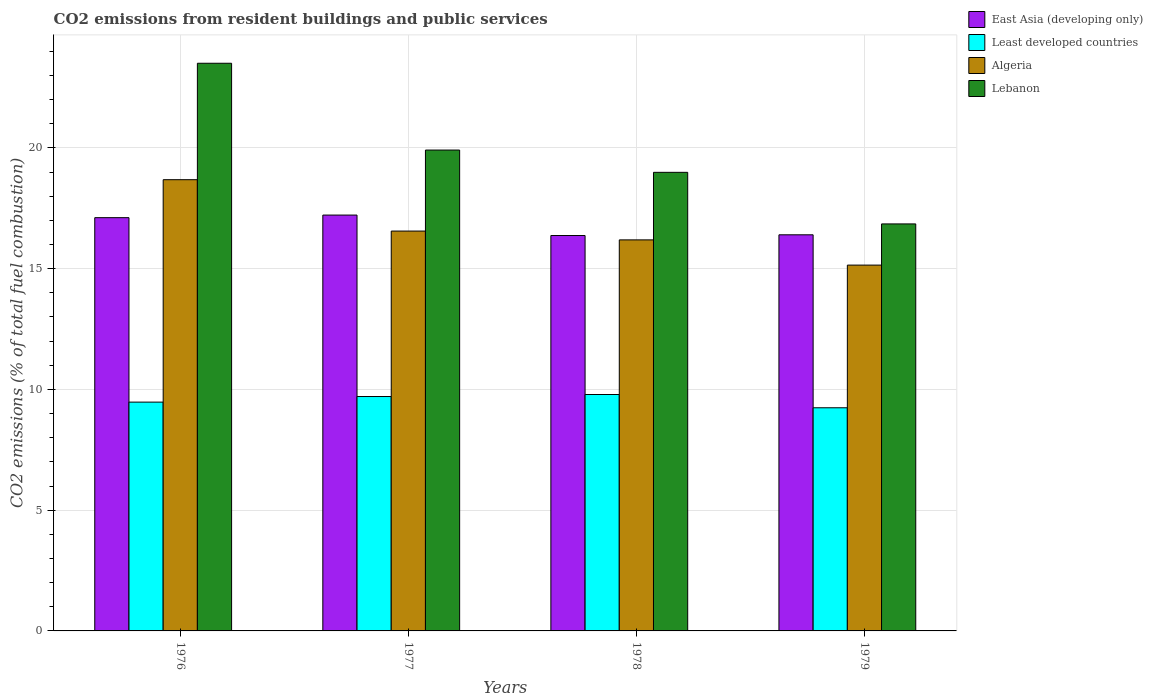How many different coloured bars are there?
Provide a short and direct response. 4. How many groups of bars are there?
Your answer should be very brief. 4. Are the number of bars on each tick of the X-axis equal?
Your response must be concise. Yes. How many bars are there on the 3rd tick from the left?
Offer a very short reply. 4. In how many cases, is the number of bars for a given year not equal to the number of legend labels?
Make the answer very short. 0. What is the total CO2 emitted in Least developed countries in 1979?
Offer a very short reply. 9.24. Across all years, what is the maximum total CO2 emitted in East Asia (developing only)?
Provide a short and direct response. 17.22. Across all years, what is the minimum total CO2 emitted in Lebanon?
Your response must be concise. 16.85. In which year was the total CO2 emitted in Lebanon maximum?
Ensure brevity in your answer.  1976. In which year was the total CO2 emitted in East Asia (developing only) minimum?
Offer a terse response. 1978. What is the total total CO2 emitted in Algeria in the graph?
Your response must be concise. 66.58. What is the difference between the total CO2 emitted in Lebanon in 1978 and that in 1979?
Your response must be concise. 2.14. What is the difference between the total CO2 emitted in Lebanon in 1977 and the total CO2 emitted in East Asia (developing only) in 1976?
Give a very brief answer. 2.8. What is the average total CO2 emitted in East Asia (developing only) per year?
Give a very brief answer. 16.78. In the year 1978, what is the difference between the total CO2 emitted in Least developed countries and total CO2 emitted in Lebanon?
Ensure brevity in your answer.  -9.2. In how many years, is the total CO2 emitted in East Asia (developing only) greater than 8?
Keep it short and to the point. 4. What is the ratio of the total CO2 emitted in Least developed countries in 1976 to that in 1979?
Your answer should be compact. 1.03. Is the difference between the total CO2 emitted in Least developed countries in 1976 and 1978 greater than the difference between the total CO2 emitted in Lebanon in 1976 and 1978?
Offer a very short reply. No. What is the difference between the highest and the second highest total CO2 emitted in Lebanon?
Ensure brevity in your answer.  3.59. What is the difference between the highest and the lowest total CO2 emitted in Lebanon?
Your answer should be very brief. 6.65. In how many years, is the total CO2 emitted in East Asia (developing only) greater than the average total CO2 emitted in East Asia (developing only) taken over all years?
Offer a terse response. 2. What does the 4th bar from the left in 1978 represents?
Give a very brief answer. Lebanon. What does the 1st bar from the right in 1979 represents?
Provide a succinct answer. Lebanon. Is it the case that in every year, the sum of the total CO2 emitted in Lebanon and total CO2 emitted in East Asia (developing only) is greater than the total CO2 emitted in Least developed countries?
Make the answer very short. Yes. How many years are there in the graph?
Make the answer very short. 4. What is the difference between two consecutive major ticks on the Y-axis?
Ensure brevity in your answer.  5. Does the graph contain any zero values?
Your response must be concise. No. How are the legend labels stacked?
Provide a short and direct response. Vertical. What is the title of the graph?
Your answer should be very brief. CO2 emissions from resident buildings and public services. What is the label or title of the Y-axis?
Provide a short and direct response. CO2 emissions (% of total fuel combustion). What is the CO2 emissions (% of total fuel combustion) in East Asia (developing only) in 1976?
Offer a very short reply. 17.11. What is the CO2 emissions (% of total fuel combustion) in Least developed countries in 1976?
Ensure brevity in your answer.  9.47. What is the CO2 emissions (% of total fuel combustion) of Algeria in 1976?
Ensure brevity in your answer.  18.69. What is the CO2 emissions (% of total fuel combustion) in Lebanon in 1976?
Your answer should be very brief. 23.51. What is the CO2 emissions (% of total fuel combustion) in East Asia (developing only) in 1977?
Your answer should be very brief. 17.22. What is the CO2 emissions (% of total fuel combustion) in Least developed countries in 1977?
Ensure brevity in your answer.  9.71. What is the CO2 emissions (% of total fuel combustion) of Algeria in 1977?
Give a very brief answer. 16.56. What is the CO2 emissions (% of total fuel combustion) of Lebanon in 1977?
Keep it short and to the point. 19.91. What is the CO2 emissions (% of total fuel combustion) in East Asia (developing only) in 1978?
Provide a short and direct response. 16.37. What is the CO2 emissions (% of total fuel combustion) of Least developed countries in 1978?
Keep it short and to the point. 9.79. What is the CO2 emissions (% of total fuel combustion) in Algeria in 1978?
Your answer should be compact. 16.19. What is the CO2 emissions (% of total fuel combustion) in Lebanon in 1978?
Give a very brief answer. 18.99. What is the CO2 emissions (% of total fuel combustion) in East Asia (developing only) in 1979?
Your answer should be compact. 16.4. What is the CO2 emissions (% of total fuel combustion) in Least developed countries in 1979?
Keep it short and to the point. 9.24. What is the CO2 emissions (% of total fuel combustion) of Algeria in 1979?
Make the answer very short. 15.15. What is the CO2 emissions (% of total fuel combustion) of Lebanon in 1979?
Your answer should be very brief. 16.85. Across all years, what is the maximum CO2 emissions (% of total fuel combustion) in East Asia (developing only)?
Ensure brevity in your answer.  17.22. Across all years, what is the maximum CO2 emissions (% of total fuel combustion) of Least developed countries?
Your answer should be very brief. 9.79. Across all years, what is the maximum CO2 emissions (% of total fuel combustion) of Algeria?
Offer a terse response. 18.69. Across all years, what is the maximum CO2 emissions (% of total fuel combustion) in Lebanon?
Offer a very short reply. 23.51. Across all years, what is the minimum CO2 emissions (% of total fuel combustion) in East Asia (developing only)?
Make the answer very short. 16.37. Across all years, what is the minimum CO2 emissions (% of total fuel combustion) of Least developed countries?
Your response must be concise. 9.24. Across all years, what is the minimum CO2 emissions (% of total fuel combustion) of Algeria?
Your answer should be compact. 15.15. Across all years, what is the minimum CO2 emissions (% of total fuel combustion) in Lebanon?
Give a very brief answer. 16.85. What is the total CO2 emissions (% of total fuel combustion) of East Asia (developing only) in the graph?
Your answer should be very brief. 67.11. What is the total CO2 emissions (% of total fuel combustion) in Least developed countries in the graph?
Make the answer very short. 38.21. What is the total CO2 emissions (% of total fuel combustion) of Algeria in the graph?
Your answer should be very brief. 66.58. What is the total CO2 emissions (% of total fuel combustion) in Lebanon in the graph?
Make the answer very short. 79.26. What is the difference between the CO2 emissions (% of total fuel combustion) of East Asia (developing only) in 1976 and that in 1977?
Your response must be concise. -0.11. What is the difference between the CO2 emissions (% of total fuel combustion) of Least developed countries in 1976 and that in 1977?
Your answer should be compact. -0.23. What is the difference between the CO2 emissions (% of total fuel combustion) of Algeria in 1976 and that in 1977?
Provide a short and direct response. 2.13. What is the difference between the CO2 emissions (% of total fuel combustion) of Lebanon in 1976 and that in 1977?
Your answer should be compact. 3.59. What is the difference between the CO2 emissions (% of total fuel combustion) of East Asia (developing only) in 1976 and that in 1978?
Keep it short and to the point. 0.74. What is the difference between the CO2 emissions (% of total fuel combustion) in Least developed countries in 1976 and that in 1978?
Offer a terse response. -0.32. What is the difference between the CO2 emissions (% of total fuel combustion) of Algeria in 1976 and that in 1978?
Provide a short and direct response. 2.49. What is the difference between the CO2 emissions (% of total fuel combustion) of Lebanon in 1976 and that in 1978?
Give a very brief answer. 4.52. What is the difference between the CO2 emissions (% of total fuel combustion) in East Asia (developing only) in 1976 and that in 1979?
Your answer should be very brief. 0.71. What is the difference between the CO2 emissions (% of total fuel combustion) of Least developed countries in 1976 and that in 1979?
Your response must be concise. 0.23. What is the difference between the CO2 emissions (% of total fuel combustion) in Algeria in 1976 and that in 1979?
Offer a terse response. 3.54. What is the difference between the CO2 emissions (% of total fuel combustion) of Lebanon in 1976 and that in 1979?
Your response must be concise. 6.65. What is the difference between the CO2 emissions (% of total fuel combustion) in East Asia (developing only) in 1977 and that in 1978?
Your answer should be very brief. 0.85. What is the difference between the CO2 emissions (% of total fuel combustion) of Least developed countries in 1977 and that in 1978?
Your answer should be very brief. -0.08. What is the difference between the CO2 emissions (% of total fuel combustion) in Algeria in 1977 and that in 1978?
Your response must be concise. 0.36. What is the difference between the CO2 emissions (% of total fuel combustion) in Lebanon in 1977 and that in 1978?
Offer a very short reply. 0.92. What is the difference between the CO2 emissions (% of total fuel combustion) of East Asia (developing only) in 1977 and that in 1979?
Provide a succinct answer. 0.82. What is the difference between the CO2 emissions (% of total fuel combustion) of Least developed countries in 1977 and that in 1979?
Provide a succinct answer. 0.47. What is the difference between the CO2 emissions (% of total fuel combustion) of Algeria in 1977 and that in 1979?
Offer a terse response. 1.41. What is the difference between the CO2 emissions (% of total fuel combustion) of Lebanon in 1977 and that in 1979?
Make the answer very short. 3.06. What is the difference between the CO2 emissions (% of total fuel combustion) of East Asia (developing only) in 1978 and that in 1979?
Keep it short and to the point. -0.03. What is the difference between the CO2 emissions (% of total fuel combustion) in Least developed countries in 1978 and that in 1979?
Provide a succinct answer. 0.55. What is the difference between the CO2 emissions (% of total fuel combustion) in Algeria in 1978 and that in 1979?
Keep it short and to the point. 1.04. What is the difference between the CO2 emissions (% of total fuel combustion) of Lebanon in 1978 and that in 1979?
Your answer should be very brief. 2.14. What is the difference between the CO2 emissions (% of total fuel combustion) in East Asia (developing only) in 1976 and the CO2 emissions (% of total fuel combustion) in Least developed countries in 1977?
Offer a very short reply. 7.41. What is the difference between the CO2 emissions (% of total fuel combustion) of East Asia (developing only) in 1976 and the CO2 emissions (% of total fuel combustion) of Algeria in 1977?
Offer a terse response. 0.56. What is the difference between the CO2 emissions (% of total fuel combustion) in East Asia (developing only) in 1976 and the CO2 emissions (% of total fuel combustion) in Lebanon in 1977?
Keep it short and to the point. -2.8. What is the difference between the CO2 emissions (% of total fuel combustion) in Least developed countries in 1976 and the CO2 emissions (% of total fuel combustion) in Algeria in 1977?
Your answer should be compact. -7.08. What is the difference between the CO2 emissions (% of total fuel combustion) of Least developed countries in 1976 and the CO2 emissions (% of total fuel combustion) of Lebanon in 1977?
Keep it short and to the point. -10.44. What is the difference between the CO2 emissions (% of total fuel combustion) in Algeria in 1976 and the CO2 emissions (% of total fuel combustion) in Lebanon in 1977?
Give a very brief answer. -1.23. What is the difference between the CO2 emissions (% of total fuel combustion) of East Asia (developing only) in 1976 and the CO2 emissions (% of total fuel combustion) of Least developed countries in 1978?
Your answer should be very brief. 7.32. What is the difference between the CO2 emissions (% of total fuel combustion) of East Asia (developing only) in 1976 and the CO2 emissions (% of total fuel combustion) of Algeria in 1978?
Your response must be concise. 0.92. What is the difference between the CO2 emissions (% of total fuel combustion) of East Asia (developing only) in 1976 and the CO2 emissions (% of total fuel combustion) of Lebanon in 1978?
Your answer should be very brief. -1.88. What is the difference between the CO2 emissions (% of total fuel combustion) of Least developed countries in 1976 and the CO2 emissions (% of total fuel combustion) of Algeria in 1978?
Your answer should be very brief. -6.72. What is the difference between the CO2 emissions (% of total fuel combustion) of Least developed countries in 1976 and the CO2 emissions (% of total fuel combustion) of Lebanon in 1978?
Your answer should be very brief. -9.51. What is the difference between the CO2 emissions (% of total fuel combustion) of Algeria in 1976 and the CO2 emissions (% of total fuel combustion) of Lebanon in 1978?
Make the answer very short. -0.3. What is the difference between the CO2 emissions (% of total fuel combustion) of East Asia (developing only) in 1976 and the CO2 emissions (% of total fuel combustion) of Least developed countries in 1979?
Make the answer very short. 7.87. What is the difference between the CO2 emissions (% of total fuel combustion) of East Asia (developing only) in 1976 and the CO2 emissions (% of total fuel combustion) of Algeria in 1979?
Your answer should be very brief. 1.96. What is the difference between the CO2 emissions (% of total fuel combustion) in East Asia (developing only) in 1976 and the CO2 emissions (% of total fuel combustion) in Lebanon in 1979?
Your answer should be very brief. 0.26. What is the difference between the CO2 emissions (% of total fuel combustion) of Least developed countries in 1976 and the CO2 emissions (% of total fuel combustion) of Algeria in 1979?
Your answer should be very brief. -5.67. What is the difference between the CO2 emissions (% of total fuel combustion) of Least developed countries in 1976 and the CO2 emissions (% of total fuel combustion) of Lebanon in 1979?
Ensure brevity in your answer.  -7.38. What is the difference between the CO2 emissions (% of total fuel combustion) of Algeria in 1976 and the CO2 emissions (% of total fuel combustion) of Lebanon in 1979?
Give a very brief answer. 1.83. What is the difference between the CO2 emissions (% of total fuel combustion) in East Asia (developing only) in 1977 and the CO2 emissions (% of total fuel combustion) in Least developed countries in 1978?
Offer a very short reply. 7.43. What is the difference between the CO2 emissions (% of total fuel combustion) in East Asia (developing only) in 1977 and the CO2 emissions (% of total fuel combustion) in Algeria in 1978?
Provide a short and direct response. 1.03. What is the difference between the CO2 emissions (% of total fuel combustion) of East Asia (developing only) in 1977 and the CO2 emissions (% of total fuel combustion) of Lebanon in 1978?
Offer a terse response. -1.77. What is the difference between the CO2 emissions (% of total fuel combustion) in Least developed countries in 1977 and the CO2 emissions (% of total fuel combustion) in Algeria in 1978?
Make the answer very short. -6.49. What is the difference between the CO2 emissions (% of total fuel combustion) of Least developed countries in 1977 and the CO2 emissions (% of total fuel combustion) of Lebanon in 1978?
Offer a terse response. -9.28. What is the difference between the CO2 emissions (% of total fuel combustion) in Algeria in 1977 and the CO2 emissions (% of total fuel combustion) in Lebanon in 1978?
Keep it short and to the point. -2.43. What is the difference between the CO2 emissions (% of total fuel combustion) of East Asia (developing only) in 1977 and the CO2 emissions (% of total fuel combustion) of Least developed countries in 1979?
Your answer should be compact. 7.98. What is the difference between the CO2 emissions (% of total fuel combustion) in East Asia (developing only) in 1977 and the CO2 emissions (% of total fuel combustion) in Algeria in 1979?
Your response must be concise. 2.07. What is the difference between the CO2 emissions (% of total fuel combustion) of East Asia (developing only) in 1977 and the CO2 emissions (% of total fuel combustion) of Lebanon in 1979?
Make the answer very short. 0.37. What is the difference between the CO2 emissions (% of total fuel combustion) in Least developed countries in 1977 and the CO2 emissions (% of total fuel combustion) in Algeria in 1979?
Make the answer very short. -5.44. What is the difference between the CO2 emissions (% of total fuel combustion) of Least developed countries in 1977 and the CO2 emissions (% of total fuel combustion) of Lebanon in 1979?
Offer a very short reply. -7.15. What is the difference between the CO2 emissions (% of total fuel combustion) of Algeria in 1977 and the CO2 emissions (% of total fuel combustion) of Lebanon in 1979?
Your answer should be compact. -0.3. What is the difference between the CO2 emissions (% of total fuel combustion) in East Asia (developing only) in 1978 and the CO2 emissions (% of total fuel combustion) in Least developed countries in 1979?
Your answer should be very brief. 7.13. What is the difference between the CO2 emissions (% of total fuel combustion) of East Asia (developing only) in 1978 and the CO2 emissions (% of total fuel combustion) of Algeria in 1979?
Your answer should be very brief. 1.23. What is the difference between the CO2 emissions (% of total fuel combustion) of East Asia (developing only) in 1978 and the CO2 emissions (% of total fuel combustion) of Lebanon in 1979?
Make the answer very short. -0.48. What is the difference between the CO2 emissions (% of total fuel combustion) in Least developed countries in 1978 and the CO2 emissions (% of total fuel combustion) in Algeria in 1979?
Provide a short and direct response. -5.36. What is the difference between the CO2 emissions (% of total fuel combustion) in Least developed countries in 1978 and the CO2 emissions (% of total fuel combustion) in Lebanon in 1979?
Your answer should be compact. -7.06. What is the difference between the CO2 emissions (% of total fuel combustion) in Algeria in 1978 and the CO2 emissions (% of total fuel combustion) in Lebanon in 1979?
Your answer should be compact. -0.66. What is the average CO2 emissions (% of total fuel combustion) in East Asia (developing only) per year?
Ensure brevity in your answer.  16.78. What is the average CO2 emissions (% of total fuel combustion) of Least developed countries per year?
Your answer should be very brief. 9.55. What is the average CO2 emissions (% of total fuel combustion) in Algeria per year?
Offer a very short reply. 16.65. What is the average CO2 emissions (% of total fuel combustion) of Lebanon per year?
Make the answer very short. 19.82. In the year 1976, what is the difference between the CO2 emissions (% of total fuel combustion) in East Asia (developing only) and CO2 emissions (% of total fuel combustion) in Least developed countries?
Offer a very short reply. 7.64. In the year 1976, what is the difference between the CO2 emissions (% of total fuel combustion) of East Asia (developing only) and CO2 emissions (% of total fuel combustion) of Algeria?
Keep it short and to the point. -1.57. In the year 1976, what is the difference between the CO2 emissions (% of total fuel combustion) in East Asia (developing only) and CO2 emissions (% of total fuel combustion) in Lebanon?
Your answer should be compact. -6.39. In the year 1976, what is the difference between the CO2 emissions (% of total fuel combustion) of Least developed countries and CO2 emissions (% of total fuel combustion) of Algeria?
Provide a succinct answer. -9.21. In the year 1976, what is the difference between the CO2 emissions (% of total fuel combustion) of Least developed countries and CO2 emissions (% of total fuel combustion) of Lebanon?
Your answer should be very brief. -14.03. In the year 1976, what is the difference between the CO2 emissions (% of total fuel combustion) in Algeria and CO2 emissions (% of total fuel combustion) in Lebanon?
Your answer should be compact. -4.82. In the year 1977, what is the difference between the CO2 emissions (% of total fuel combustion) in East Asia (developing only) and CO2 emissions (% of total fuel combustion) in Least developed countries?
Your answer should be compact. 7.51. In the year 1977, what is the difference between the CO2 emissions (% of total fuel combustion) in East Asia (developing only) and CO2 emissions (% of total fuel combustion) in Algeria?
Provide a succinct answer. 0.66. In the year 1977, what is the difference between the CO2 emissions (% of total fuel combustion) of East Asia (developing only) and CO2 emissions (% of total fuel combustion) of Lebanon?
Provide a short and direct response. -2.69. In the year 1977, what is the difference between the CO2 emissions (% of total fuel combustion) in Least developed countries and CO2 emissions (% of total fuel combustion) in Algeria?
Your answer should be very brief. -6.85. In the year 1977, what is the difference between the CO2 emissions (% of total fuel combustion) in Least developed countries and CO2 emissions (% of total fuel combustion) in Lebanon?
Make the answer very short. -10.21. In the year 1977, what is the difference between the CO2 emissions (% of total fuel combustion) in Algeria and CO2 emissions (% of total fuel combustion) in Lebanon?
Give a very brief answer. -3.36. In the year 1978, what is the difference between the CO2 emissions (% of total fuel combustion) in East Asia (developing only) and CO2 emissions (% of total fuel combustion) in Least developed countries?
Offer a very short reply. 6.58. In the year 1978, what is the difference between the CO2 emissions (% of total fuel combustion) of East Asia (developing only) and CO2 emissions (% of total fuel combustion) of Algeria?
Your response must be concise. 0.18. In the year 1978, what is the difference between the CO2 emissions (% of total fuel combustion) of East Asia (developing only) and CO2 emissions (% of total fuel combustion) of Lebanon?
Your answer should be very brief. -2.62. In the year 1978, what is the difference between the CO2 emissions (% of total fuel combustion) in Least developed countries and CO2 emissions (% of total fuel combustion) in Algeria?
Provide a short and direct response. -6.4. In the year 1978, what is the difference between the CO2 emissions (% of total fuel combustion) of Least developed countries and CO2 emissions (% of total fuel combustion) of Lebanon?
Offer a terse response. -9.2. In the year 1978, what is the difference between the CO2 emissions (% of total fuel combustion) of Algeria and CO2 emissions (% of total fuel combustion) of Lebanon?
Provide a short and direct response. -2.8. In the year 1979, what is the difference between the CO2 emissions (% of total fuel combustion) in East Asia (developing only) and CO2 emissions (% of total fuel combustion) in Least developed countries?
Keep it short and to the point. 7.16. In the year 1979, what is the difference between the CO2 emissions (% of total fuel combustion) of East Asia (developing only) and CO2 emissions (% of total fuel combustion) of Algeria?
Ensure brevity in your answer.  1.25. In the year 1979, what is the difference between the CO2 emissions (% of total fuel combustion) in East Asia (developing only) and CO2 emissions (% of total fuel combustion) in Lebanon?
Offer a very short reply. -0.45. In the year 1979, what is the difference between the CO2 emissions (% of total fuel combustion) in Least developed countries and CO2 emissions (% of total fuel combustion) in Algeria?
Your answer should be compact. -5.91. In the year 1979, what is the difference between the CO2 emissions (% of total fuel combustion) of Least developed countries and CO2 emissions (% of total fuel combustion) of Lebanon?
Your answer should be very brief. -7.61. In the year 1979, what is the difference between the CO2 emissions (% of total fuel combustion) of Algeria and CO2 emissions (% of total fuel combustion) of Lebanon?
Keep it short and to the point. -1.71. What is the ratio of the CO2 emissions (% of total fuel combustion) of East Asia (developing only) in 1976 to that in 1977?
Ensure brevity in your answer.  0.99. What is the ratio of the CO2 emissions (% of total fuel combustion) in Least developed countries in 1976 to that in 1977?
Keep it short and to the point. 0.98. What is the ratio of the CO2 emissions (% of total fuel combustion) of Algeria in 1976 to that in 1977?
Offer a very short reply. 1.13. What is the ratio of the CO2 emissions (% of total fuel combustion) in Lebanon in 1976 to that in 1977?
Offer a very short reply. 1.18. What is the ratio of the CO2 emissions (% of total fuel combustion) of East Asia (developing only) in 1976 to that in 1978?
Your answer should be compact. 1.05. What is the ratio of the CO2 emissions (% of total fuel combustion) in Least developed countries in 1976 to that in 1978?
Make the answer very short. 0.97. What is the ratio of the CO2 emissions (% of total fuel combustion) of Algeria in 1976 to that in 1978?
Your answer should be very brief. 1.15. What is the ratio of the CO2 emissions (% of total fuel combustion) of Lebanon in 1976 to that in 1978?
Provide a short and direct response. 1.24. What is the ratio of the CO2 emissions (% of total fuel combustion) of East Asia (developing only) in 1976 to that in 1979?
Ensure brevity in your answer.  1.04. What is the ratio of the CO2 emissions (% of total fuel combustion) in Least developed countries in 1976 to that in 1979?
Offer a very short reply. 1.03. What is the ratio of the CO2 emissions (% of total fuel combustion) in Algeria in 1976 to that in 1979?
Offer a terse response. 1.23. What is the ratio of the CO2 emissions (% of total fuel combustion) of Lebanon in 1976 to that in 1979?
Keep it short and to the point. 1.39. What is the ratio of the CO2 emissions (% of total fuel combustion) in East Asia (developing only) in 1977 to that in 1978?
Provide a short and direct response. 1.05. What is the ratio of the CO2 emissions (% of total fuel combustion) in Least developed countries in 1977 to that in 1978?
Your answer should be compact. 0.99. What is the ratio of the CO2 emissions (% of total fuel combustion) in Algeria in 1977 to that in 1978?
Your answer should be very brief. 1.02. What is the ratio of the CO2 emissions (% of total fuel combustion) of Lebanon in 1977 to that in 1978?
Offer a terse response. 1.05. What is the ratio of the CO2 emissions (% of total fuel combustion) in East Asia (developing only) in 1977 to that in 1979?
Make the answer very short. 1.05. What is the ratio of the CO2 emissions (% of total fuel combustion) in Least developed countries in 1977 to that in 1979?
Your answer should be compact. 1.05. What is the ratio of the CO2 emissions (% of total fuel combustion) in Algeria in 1977 to that in 1979?
Your answer should be compact. 1.09. What is the ratio of the CO2 emissions (% of total fuel combustion) of Lebanon in 1977 to that in 1979?
Your response must be concise. 1.18. What is the ratio of the CO2 emissions (% of total fuel combustion) in Least developed countries in 1978 to that in 1979?
Provide a succinct answer. 1.06. What is the ratio of the CO2 emissions (% of total fuel combustion) in Algeria in 1978 to that in 1979?
Provide a short and direct response. 1.07. What is the ratio of the CO2 emissions (% of total fuel combustion) of Lebanon in 1978 to that in 1979?
Provide a succinct answer. 1.13. What is the difference between the highest and the second highest CO2 emissions (% of total fuel combustion) in East Asia (developing only)?
Ensure brevity in your answer.  0.11. What is the difference between the highest and the second highest CO2 emissions (% of total fuel combustion) in Least developed countries?
Offer a very short reply. 0.08. What is the difference between the highest and the second highest CO2 emissions (% of total fuel combustion) of Algeria?
Your answer should be very brief. 2.13. What is the difference between the highest and the second highest CO2 emissions (% of total fuel combustion) of Lebanon?
Keep it short and to the point. 3.59. What is the difference between the highest and the lowest CO2 emissions (% of total fuel combustion) in East Asia (developing only)?
Your response must be concise. 0.85. What is the difference between the highest and the lowest CO2 emissions (% of total fuel combustion) of Least developed countries?
Offer a terse response. 0.55. What is the difference between the highest and the lowest CO2 emissions (% of total fuel combustion) of Algeria?
Provide a succinct answer. 3.54. What is the difference between the highest and the lowest CO2 emissions (% of total fuel combustion) of Lebanon?
Your answer should be compact. 6.65. 